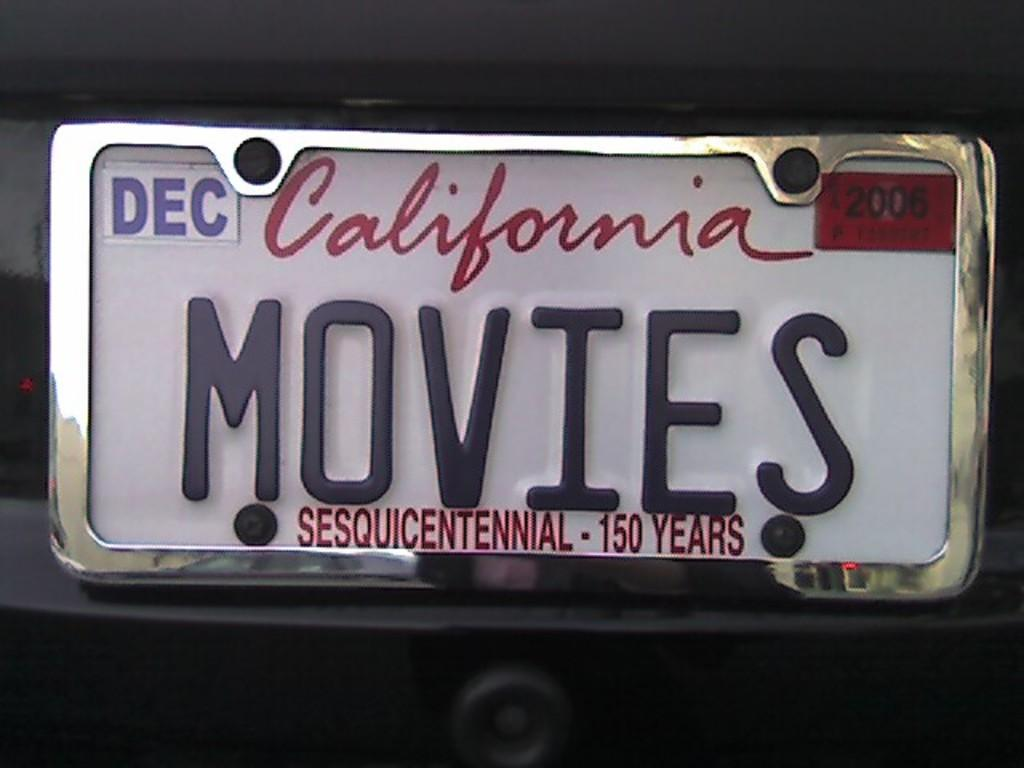<image>
Provide a brief description of the given image. A California personalized tag that reads MOVIES and expired in December of 06. 